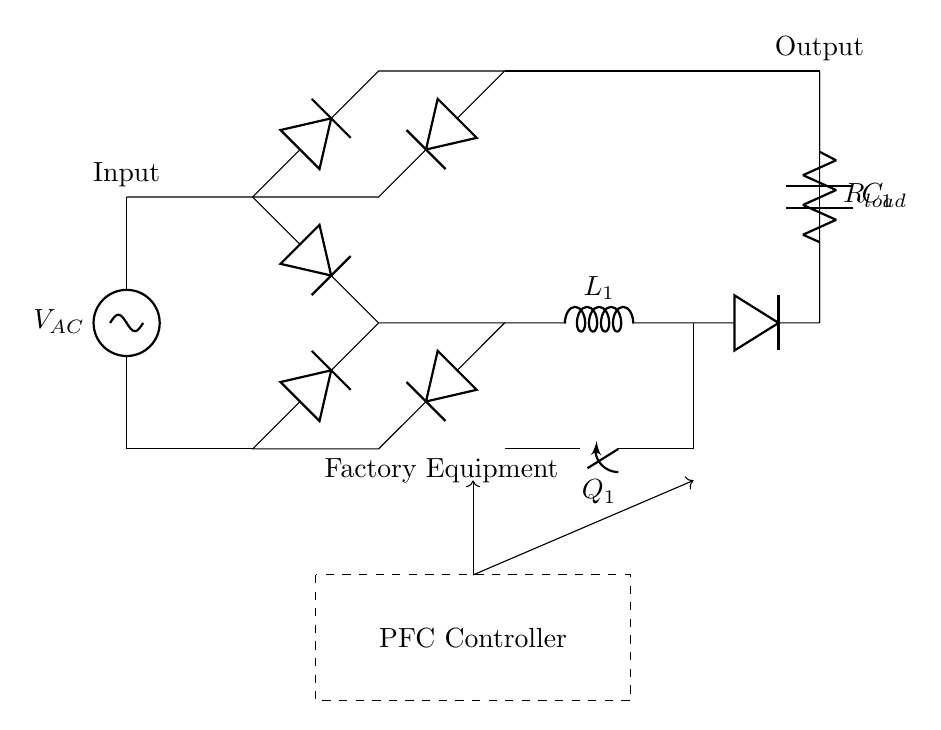What is the type of input voltage in this circuit? The input voltage is denoted as V_AC, indicating it is an alternating current (AC) voltage source.
Answer: AC What component is used to smooth the output voltage? The component used for smoothing is the capacitor labeled C_1, which stores electrical energy and releases it to smooth out fluctuations in voltage.
Answer: Capacitor How many diodes are there in the circuit? The circuit diagram shows a total of four diodes used in the bridge rectifier configuration to convert AC to DC.
Answer: Four What is the function of the inductor in this circuit? The inductor labeled L1 stores energy in a magnetic field and is part of the boost converter to increase voltage.
Answer: Energy storage What is the purpose of the PFC controller in this circuit? The PFC controller manages the operation of the circuit, ensuring that the power factor is corrected for better efficiency and lower losses in the factory equipment.
Answer: Efficiency improvement What type of load is represented in the circuit? The load is represented by a resistor, labeled R_load, indicating it is a resistive load which consumes power in the circuit.
Answer: Resistor 